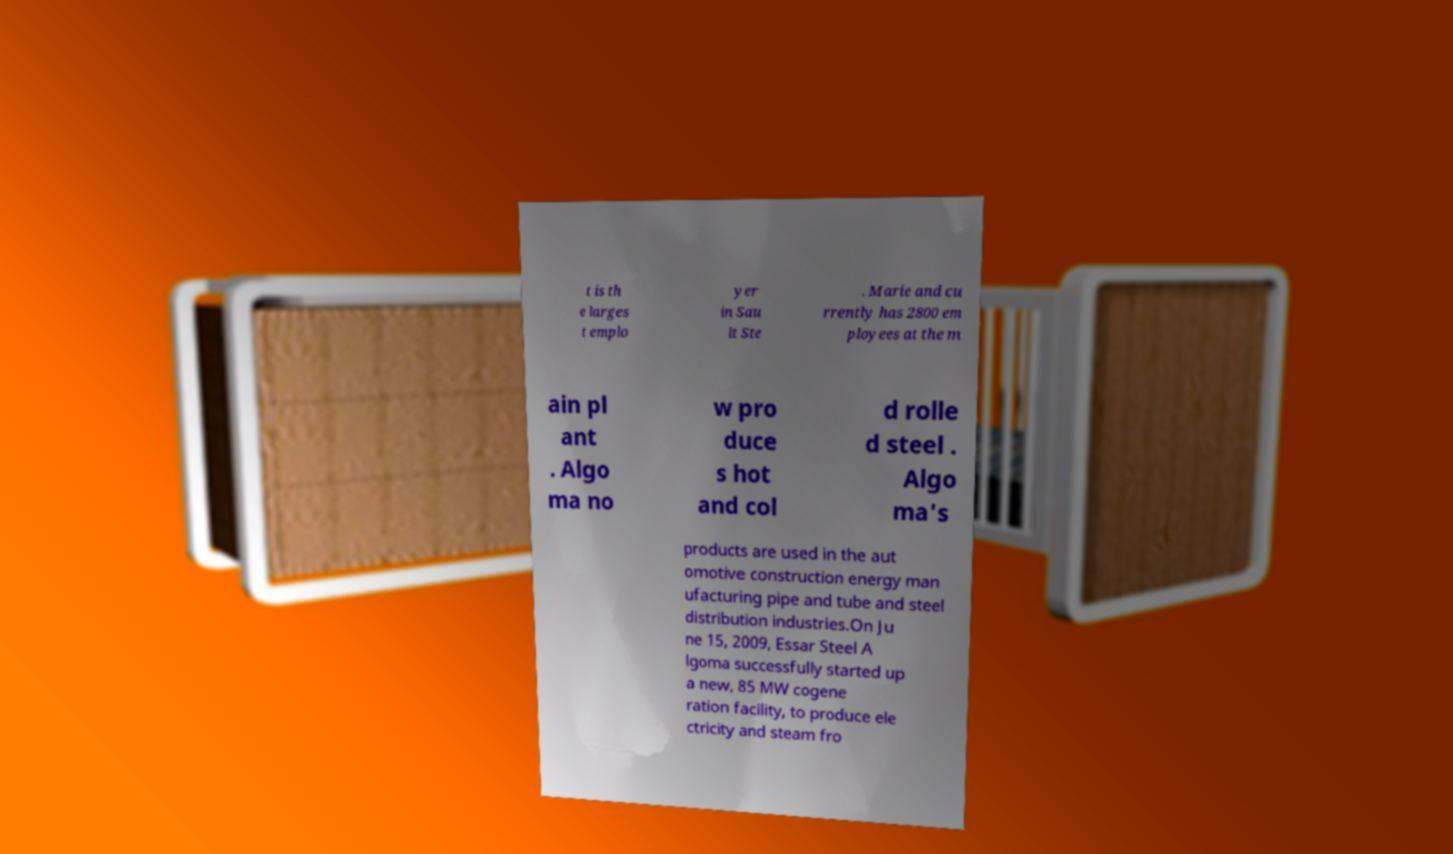I need the written content from this picture converted into text. Can you do that? t is th e larges t emplo yer in Sau lt Ste . Marie and cu rrently has 2800 em ployees at the m ain pl ant . Algo ma no w pro duce s hot and col d rolle d steel . Algo ma's products are used in the aut omotive construction energy man ufacturing pipe and tube and steel distribution industries.On Ju ne 15, 2009, Essar Steel A lgoma successfully started up a new, 85 MW cogene ration facility, to produce ele ctricity and steam fro 